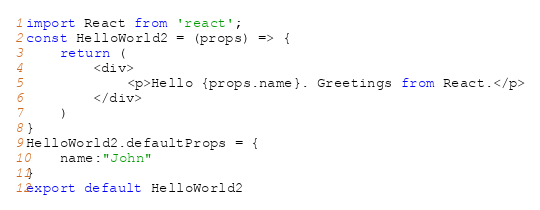Convert code to text. <code><loc_0><loc_0><loc_500><loc_500><_JavaScript_>import React from 'react';
const HelloWorld2 = (props) => {
    return (
        <div>
            <p>Hello {props.name}. Greetings from React.</p>
        </div>
    )
}
HelloWorld2.defaultProps = {
    name:"John"
}
export default HelloWorld2</code> 